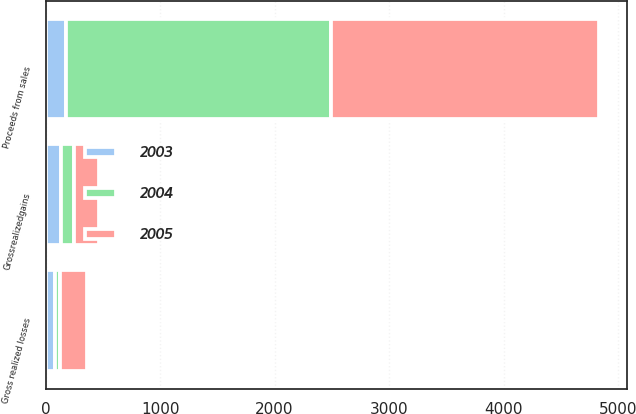Convert chart. <chart><loc_0><loc_0><loc_500><loc_500><stacked_bar_chart><ecel><fcel>Proceeds from sales<fcel>Grossrealizedgains<fcel>Gross realized losses<nl><fcel>2003<fcel>174.5<fcel>130<fcel>81<nl><fcel>2004<fcel>2320<fcel>115<fcel>43<nl><fcel>2005<fcel>2341<fcel>219<fcel>235<nl></chart> 